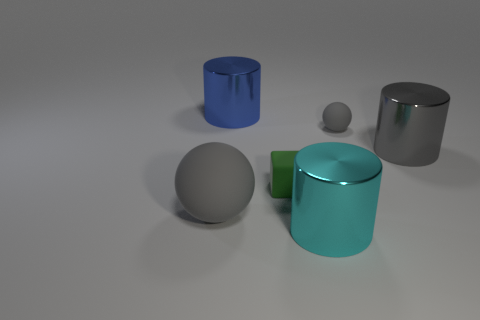Is the color of the large shiny object on the right side of the small gray rubber sphere the same as the big ball?
Ensure brevity in your answer.  Yes. Does the large rubber sphere have the same color as the tiny ball?
Offer a terse response. Yes. Is there a large sphere that has the same color as the small matte sphere?
Make the answer very short. Yes. There is a big metallic cylinder right of the small gray object; what number of metallic cylinders are behind it?
Provide a short and direct response. 1. What number of other big cylinders are the same material as the big gray cylinder?
Keep it short and to the point. 2. How many big objects are either red matte balls or gray spheres?
Provide a short and direct response. 1. The object that is to the left of the small green matte thing and to the right of the big gray rubber object has what shape?
Offer a very short reply. Cylinder. Is the material of the cyan object the same as the blue cylinder?
Ensure brevity in your answer.  Yes. What color is the matte object that is the same size as the blue cylinder?
Offer a terse response. Gray. What is the color of the thing that is in front of the large gray metallic cylinder and on the right side of the small green cube?
Offer a very short reply. Cyan. 